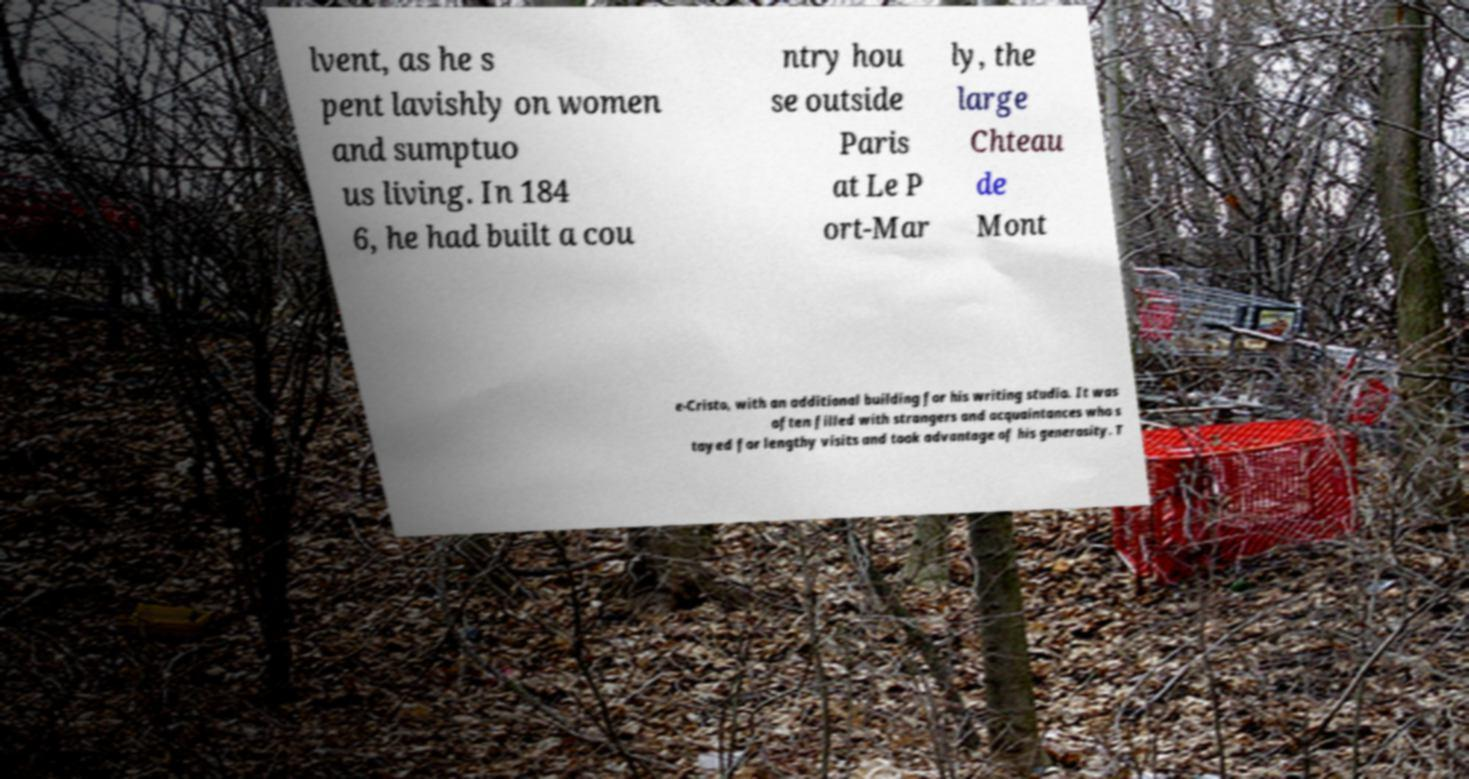Can you read and provide the text displayed in the image?This photo seems to have some interesting text. Can you extract and type it out for me? lvent, as he s pent lavishly on women and sumptuo us living. In 184 6, he had built a cou ntry hou se outside Paris at Le P ort-Mar ly, the large Chteau de Mont e-Cristo, with an additional building for his writing studio. It was often filled with strangers and acquaintances who s tayed for lengthy visits and took advantage of his generosity. T 